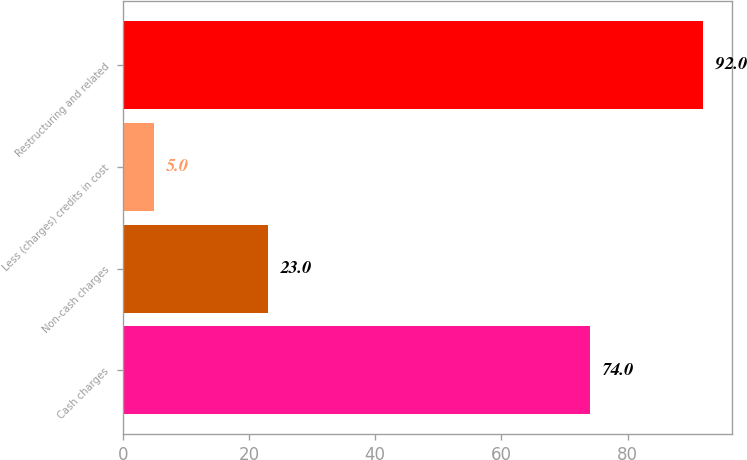Convert chart to OTSL. <chart><loc_0><loc_0><loc_500><loc_500><bar_chart><fcel>Cash charges<fcel>Non-cash charges<fcel>Less (charges) credits in cost<fcel>Restructuring and related<nl><fcel>74<fcel>23<fcel>5<fcel>92<nl></chart> 